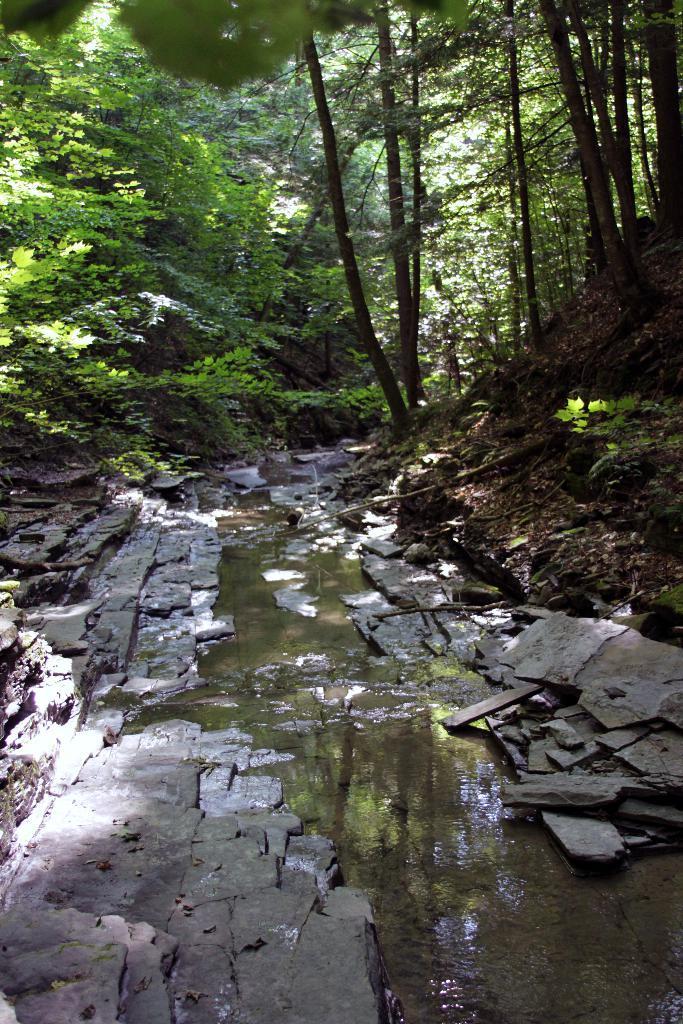Can you describe this image briefly? In the image we can see there is a water in between the footpath area, behind there are lot of trees. There are dry leaves on the ground. 